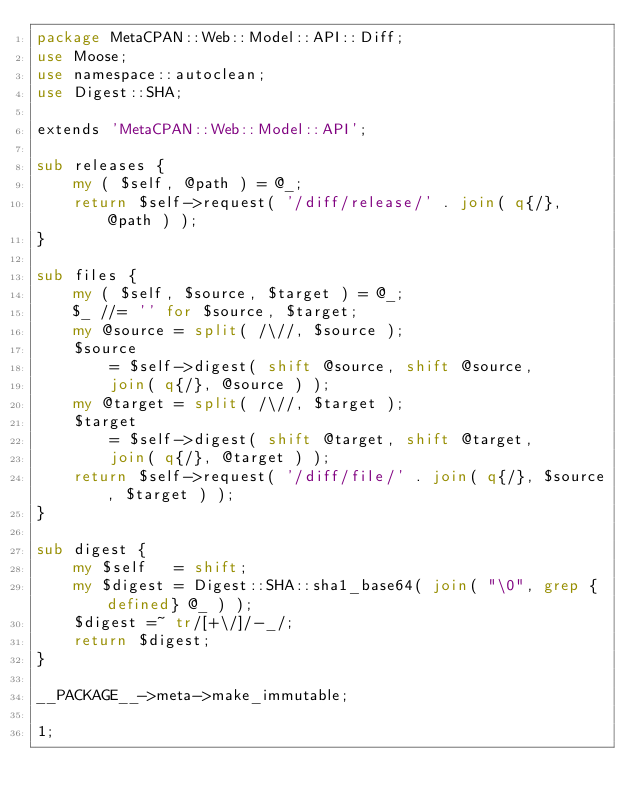Convert code to text. <code><loc_0><loc_0><loc_500><loc_500><_Perl_>package MetaCPAN::Web::Model::API::Diff;
use Moose;
use namespace::autoclean;
use Digest::SHA;

extends 'MetaCPAN::Web::Model::API';

sub releases {
    my ( $self, @path ) = @_;
    return $self->request( '/diff/release/' . join( q{/}, @path ) );
}

sub files {
    my ( $self, $source, $target ) = @_;
    $_ //= '' for $source, $target;
    my @source = split( /\//, $source );
    $source
        = $self->digest( shift @source, shift @source,
        join( q{/}, @source ) );
    my @target = split( /\//, $target );
    $target
        = $self->digest( shift @target, shift @target,
        join( q{/}, @target ) );
    return $self->request( '/diff/file/' . join( q{/}, $source, $target ) );
}

sub digest {
    my $self   = shift;
    my $digest = Digest::SHA::sha1_base64( join( "\0", grep {defined} @_ ) );
    $digest =~ tr/[+\/]/-_/;
    return $digest;
}

__PACKAGE__->meta->make_immutable;

1;
</code> 